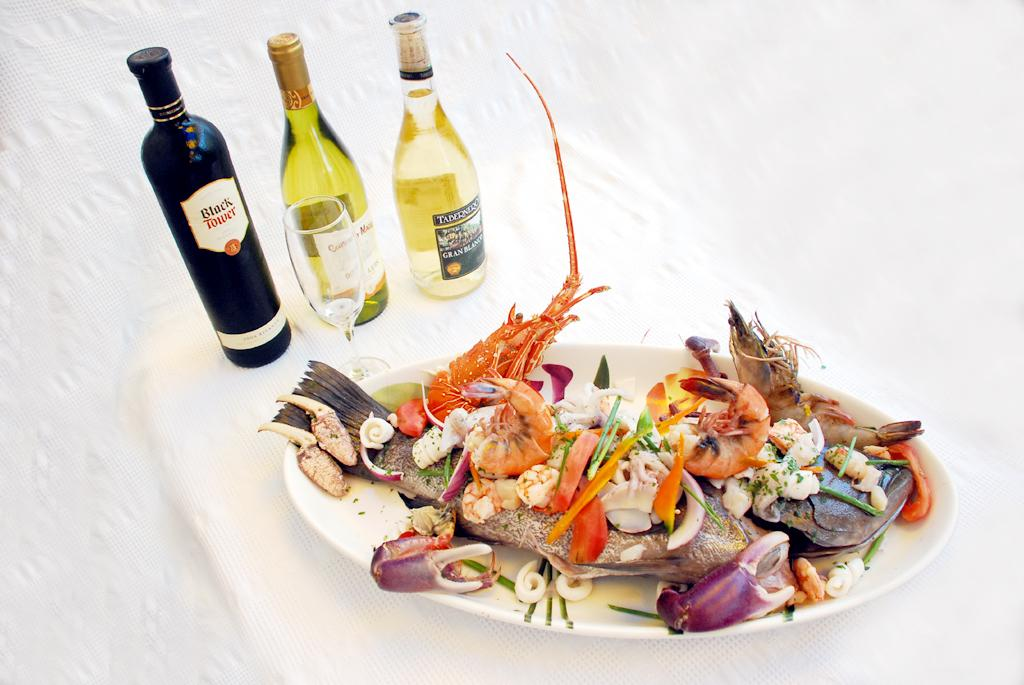How many bottles are on the table in the image? There are three bottles on the table. What else is on the table besides the bottles? There is a glass, a plate, and food on the table. What type of pickle is being used to hold the band together in the image? There is no pickle or band present in the image. Is there a book visible on the table in the image? No, there is no book visible on the table in the image. 